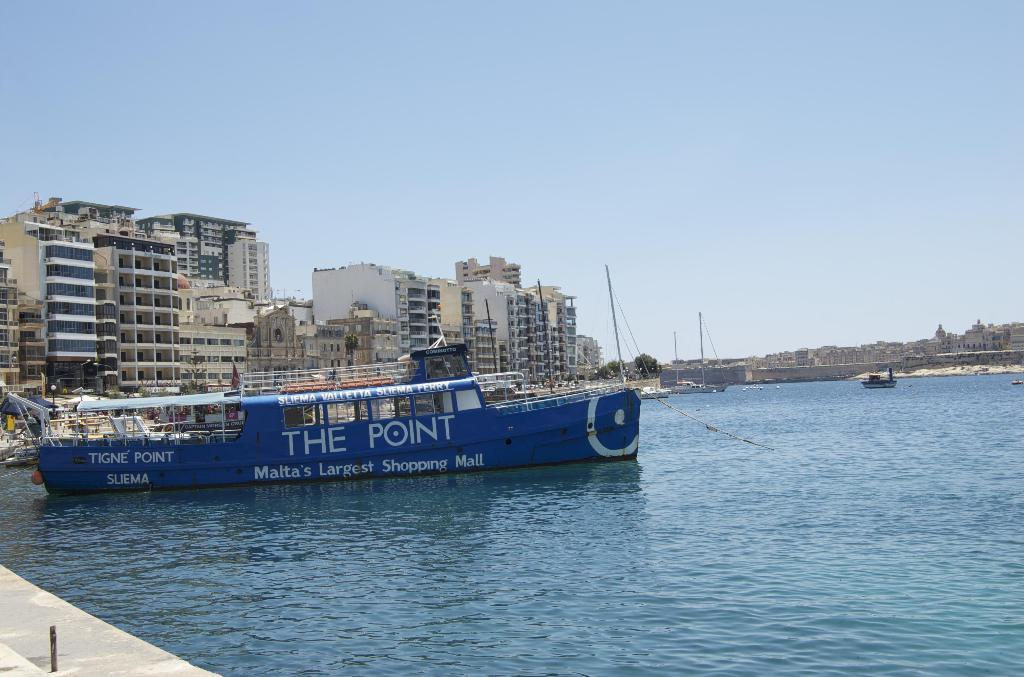<image>
Give a short and clear explanation of the subsequent image. Blue ship that has the words The Point in white. 